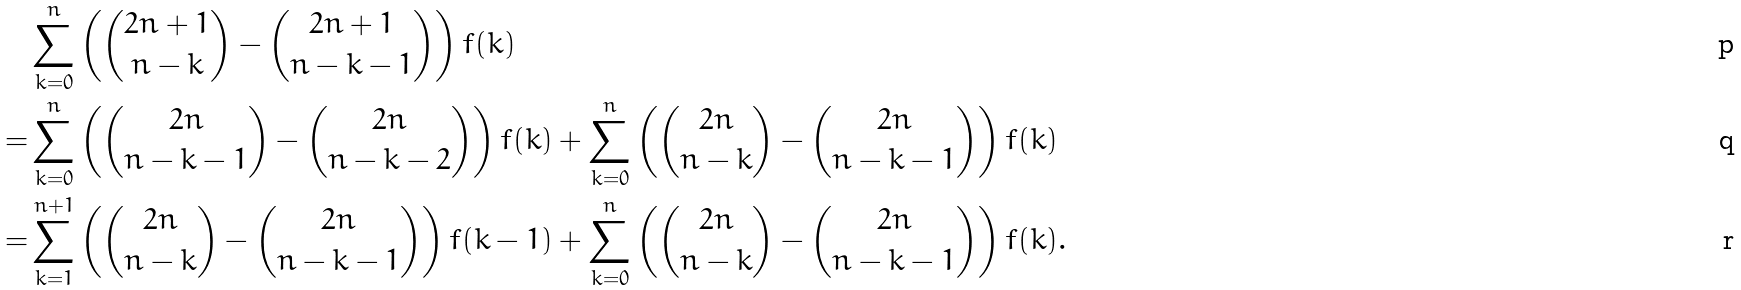Convert formula to latex. <formula><loc_0><loc_0><loc_500><loc_500>& \sum _ { k = 0 } ^ { n } \left ( \binom { 2 n + 1 } { n - k } - \binom { 2 n + 1 } { n - k - 1 } \right ) f ( k ) \\ = & \sum _ { k = 0 } ^ { n } \left ( \binom { 2 n } { n - k - 1 } - \binom { 2 n } { n - k - 2 } \right ) f ( k ) + \sum _ { k = 0 } ^ { n } \left ( \binom { 2 n } { n - k } - \binom { 2 n } { n - k - 1 } \right ) f ( k ) \\ = & \sum _ { k = 1 } ^ { n + 1 } \left ( \binom { 2 n } { n - k } - \binom { 2 n } { n - k - 1 } \right ) f ( k - 1 ) + \sum _ { k = 0 } ^ { n } \left ( \binom { 2 n } { n - k } - \binom { 2 n } { n - k - 1 } \right ) f ( k ) .</formula> 